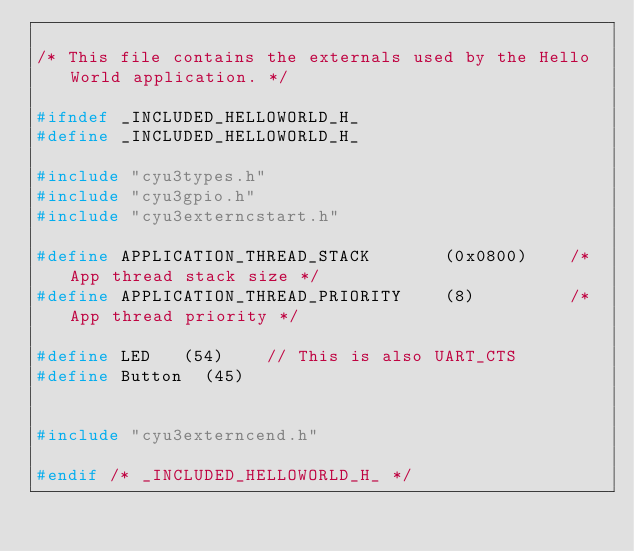<code> <loc_0><loc_0><loc_500><loc_500><_C_>
/* This file contains the externals used by the Hello World application. */

#ifndef _INCLUDED_HELLOWORLD_H_
#define _INCLUDED_HELLOWORLD_H_

#include "cyu3types.h"
#include "cyu3gpio.h"
#include "cyu3externcstart.h"

#define APPLICATION_THREAD_STACK       (0x0800)    /* App thread stack size */
#define APPLICATION_THREAD_PRIORITY    (8)         /* App thread priority */

#define LED		(54)		// This is also UART_CTS
#define Button	(45)


#include "cyu3externcend.h"

#endif /* _INCLUDED_HELLOWORLD_H_ */

</code> 